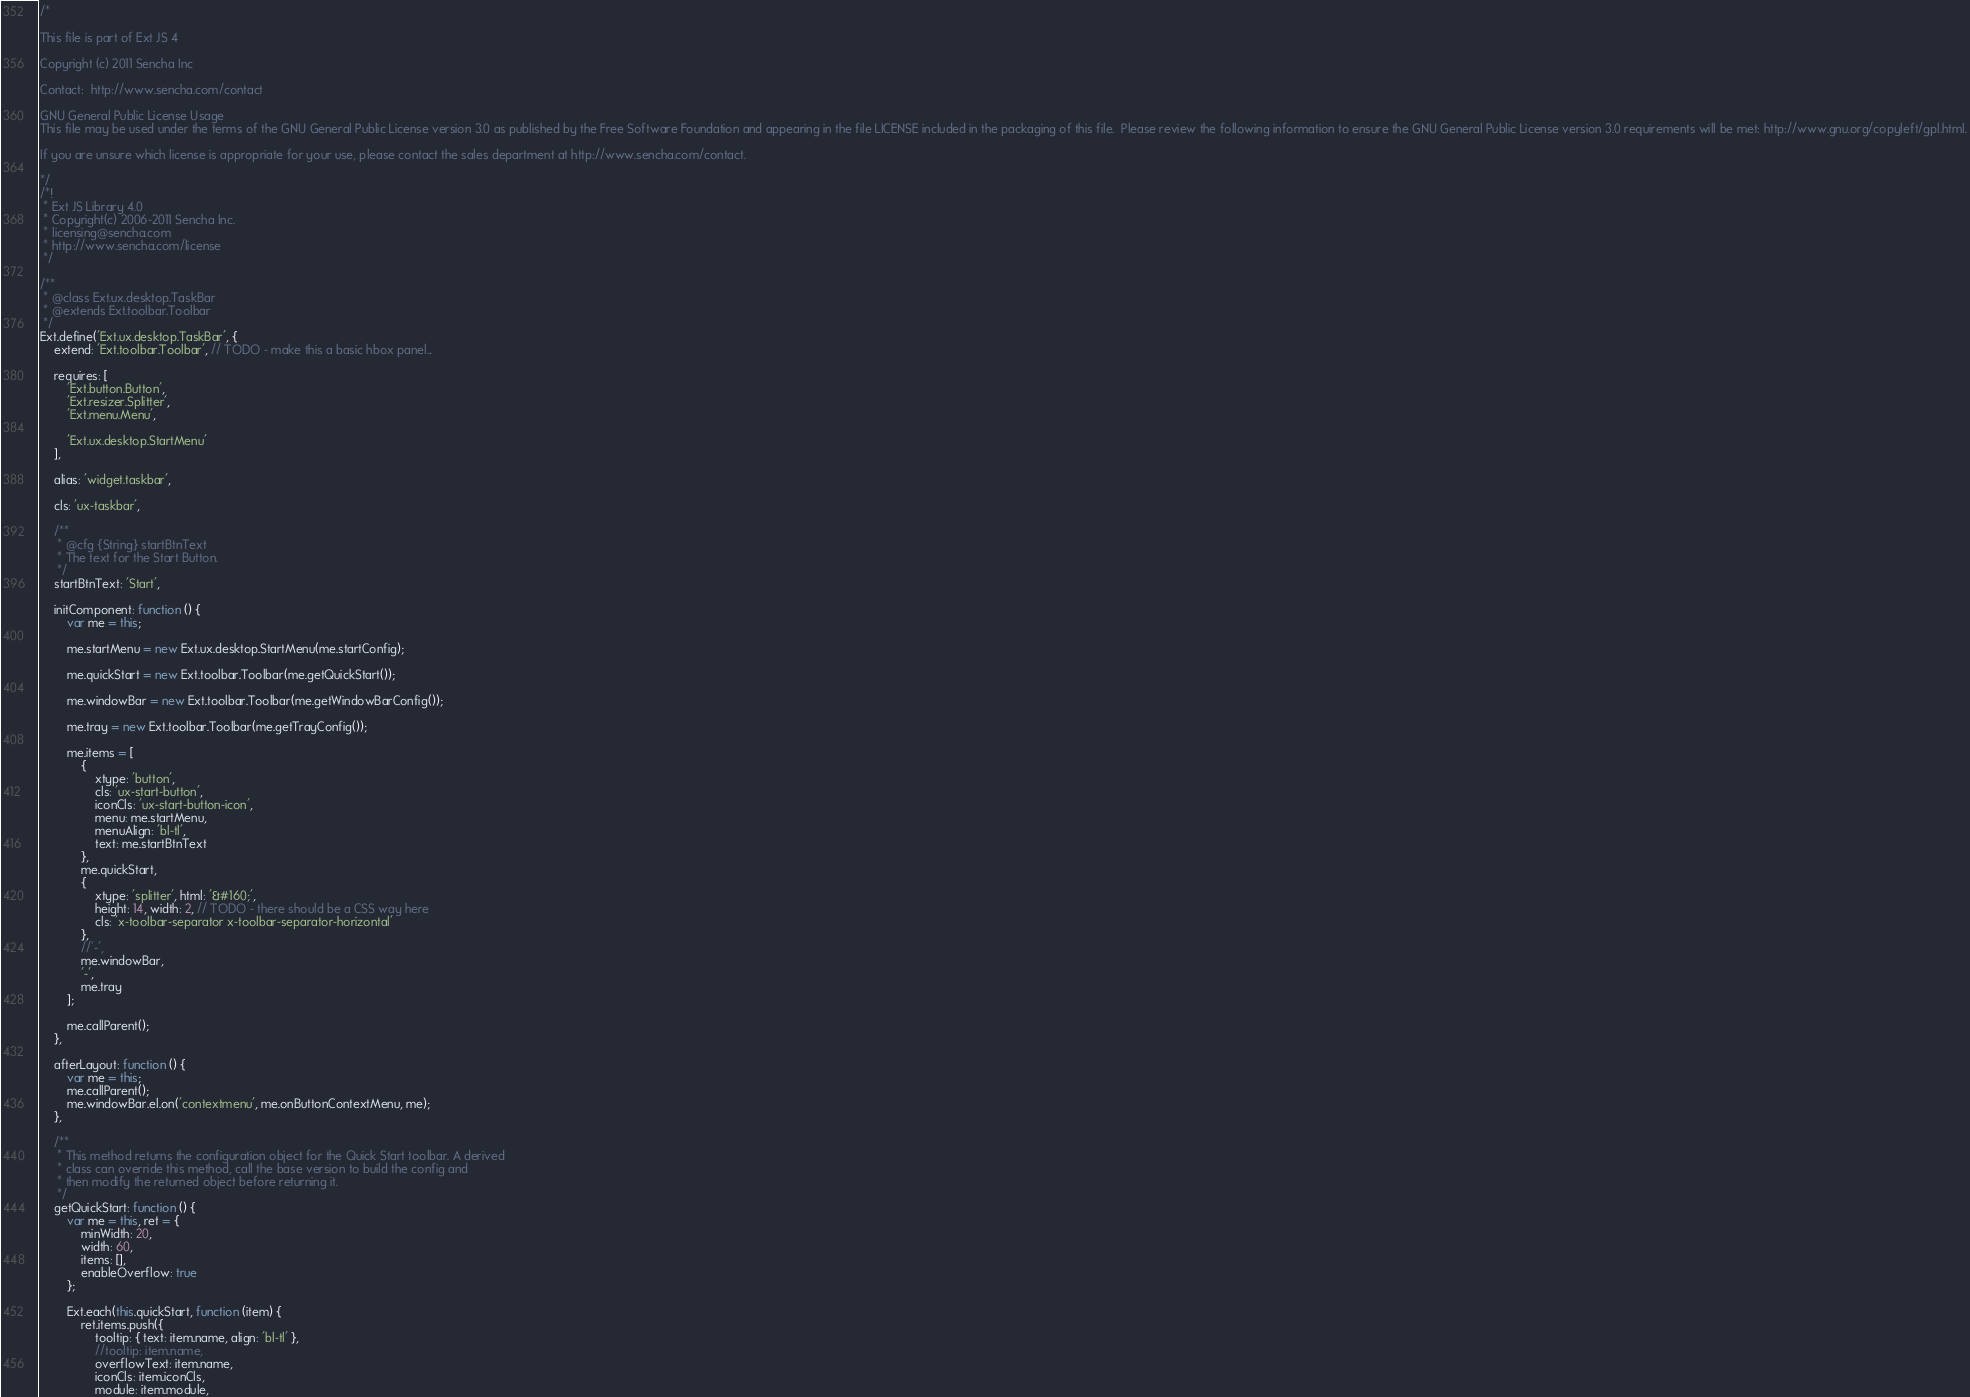<code> <loc_0><loc_0><loc_500><loc_500><_JavaScript_>/*

This file is part of Ext JS 4

Copyright (c) 2011 Sencha Inc

Contact:  http://www.sencha.com/contact

GNU General Public License Usage
This file may be used under the terms of the GNU General Public License version 3.0 as published by the Free Software Foundation and appearing in the file LICENSE included in the packaging of this file.  Please review the following information to ensure the GNU General Public License version 3.0 requirements will be met: http://www.gnu.org/copyleft/gpl.html.

If you are unsure which license is appropriate for your use, please contact the sales department at http://www.sencha.com/contact.

*/
/*!
 * Ext JS Library 4.0
 * Copyright(c) 2006-2011 Sencha Inc.
 * licensing@sencha.com
 * http://www.sencha.com/license
 */

/**
 * @class Ext.ux.desktop.TaskBar
 * @extends Ext.toolbar.Toolbar
 */
Ext.define('Ext.ux.desktop.TaskBar', {
    extend: 'Ext.toolbar.Toolbar', // TODO - make this a basic hbox panel...

    requires: [
        'Ext.button.Button',
        'Ext.resizer.Splitter',
        'Ext.menu.Menu',

        'Ext.ux.desktop.StartMenu'
    ],

    alias: 'widget.taskbar',

    cls: 'ux-taskbar',

    /**
     * @cfg {String} startBtnText
     * The text for the Start Button.
     */
    startBtnText: 'Start',

    initComponent: function () {
        var me = this;

        me.startMenu = new Ext.ux.desktop.StartMenu(me.startConfig);

        me.quickStart = new Ext.toolbar.Toolbar(me.getQuickStart());

        me.windowBar = new Ext.toolbar.Toolbar(me.getWindowBarConfig());

        me.tray = new Ext.toolbar.Toolbar(me.getTrayConfig());

        me.items = [
            {
                xtype: 'button',
                cls: 'ux-start-button',
                iconCls: 'ux-start-button-icon',
                menu: me.startMenu,
                menuAlign: 'bl-tl',
                text: me.startBtnText
            },
            me.quickStart,
            {
                xtype: 'splitter', html: '&#160;',
                height: 14, width: 2, // TODO - there should be a CSS way here
                cls: 'x-toolbar-separator x-toolbar-separator-horizontal'
            },
            //'-',
            me.windowBar,
            '-',
            me.tray
        ];

        me.callParent();
    },

    afterLayout: function () {
        var me = this;
        me.callParent();
        me.windowBar.el.on('contextmenu', me.onButtonContextMenu, me);
    },

    /**
     * This method returns the configuration object for the Quick Start toolbar. A derived
     * class can override this method, call the base version to build the config and
     * then modify the returned object before returning it.
     */
    getQuickStart: function () {
        var me = this, ret = {
            minWidth: 20,
            width: 60,
            items: [],
            enableOverflow: true
        };

        Ext.each(this.quickStart, function (item) {
            ret.items.push({
                tooltip: { text: item.name, align: 'bl-tl' },
                //tooltip: item.name,
                overflowText: item.name,
                iconCls: item.iconCls,
                module: item.module,</code> 